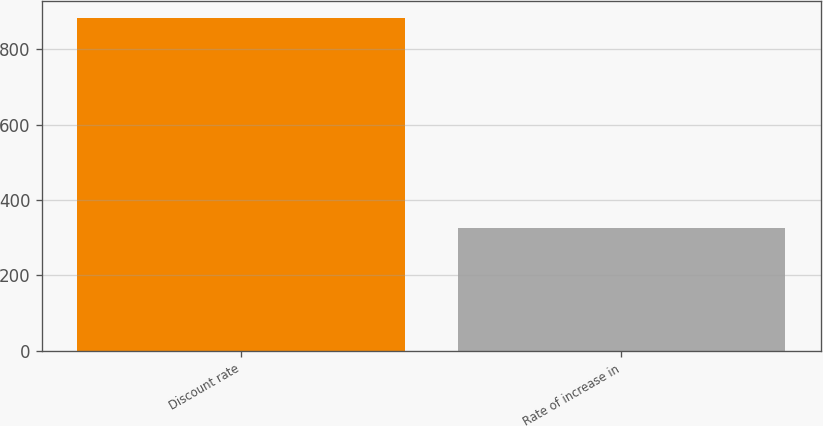<chart> <loc_0><loc_0><loc_500><loc_500><bar_chart><fcel>Discount rate<fcel>Rate of increase in<nl><fcel>884<fcel>327<nl></chart> 